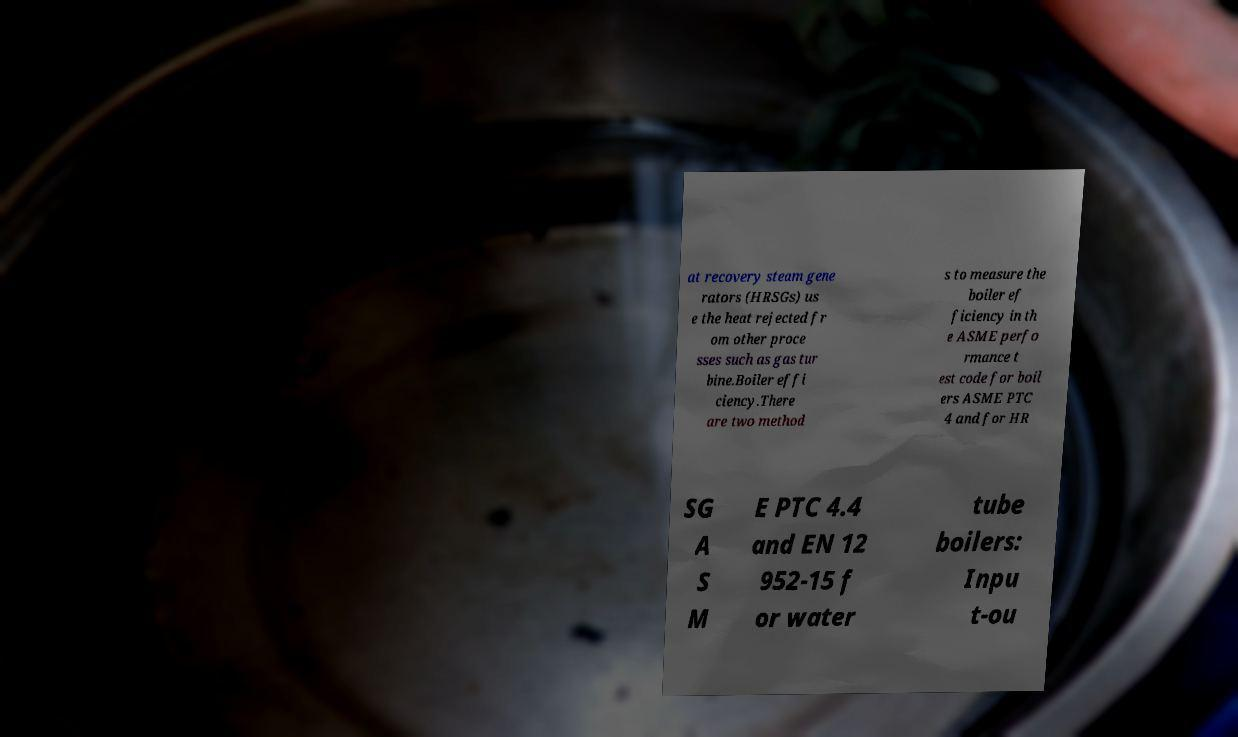Can you read and provide the text displayed in the image?This photo seems to have some interesting text. Can you extract and type it out for me? at recovery steam gene rators (HRSGs) us e the heat rejected fr om other proce sses such as gas tur bine.Boiler effi ciency.There are two method s to measure the boiler ef ficiency in th e ASME perfo rmance t est code for boil ers ASME PTC 4 and for HR SG A S M E PTC 4.4 and EN 12 952-15 f or water tube boilers: Inpu t-ou 